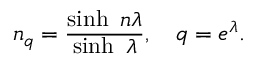<formula> <loc_0><loc_0><loc_500><loc_500>n _ { q } = \frac { \sinh n \lambda } { \sinh \lambda } , q = e ^ { \lambda } .</formula> 